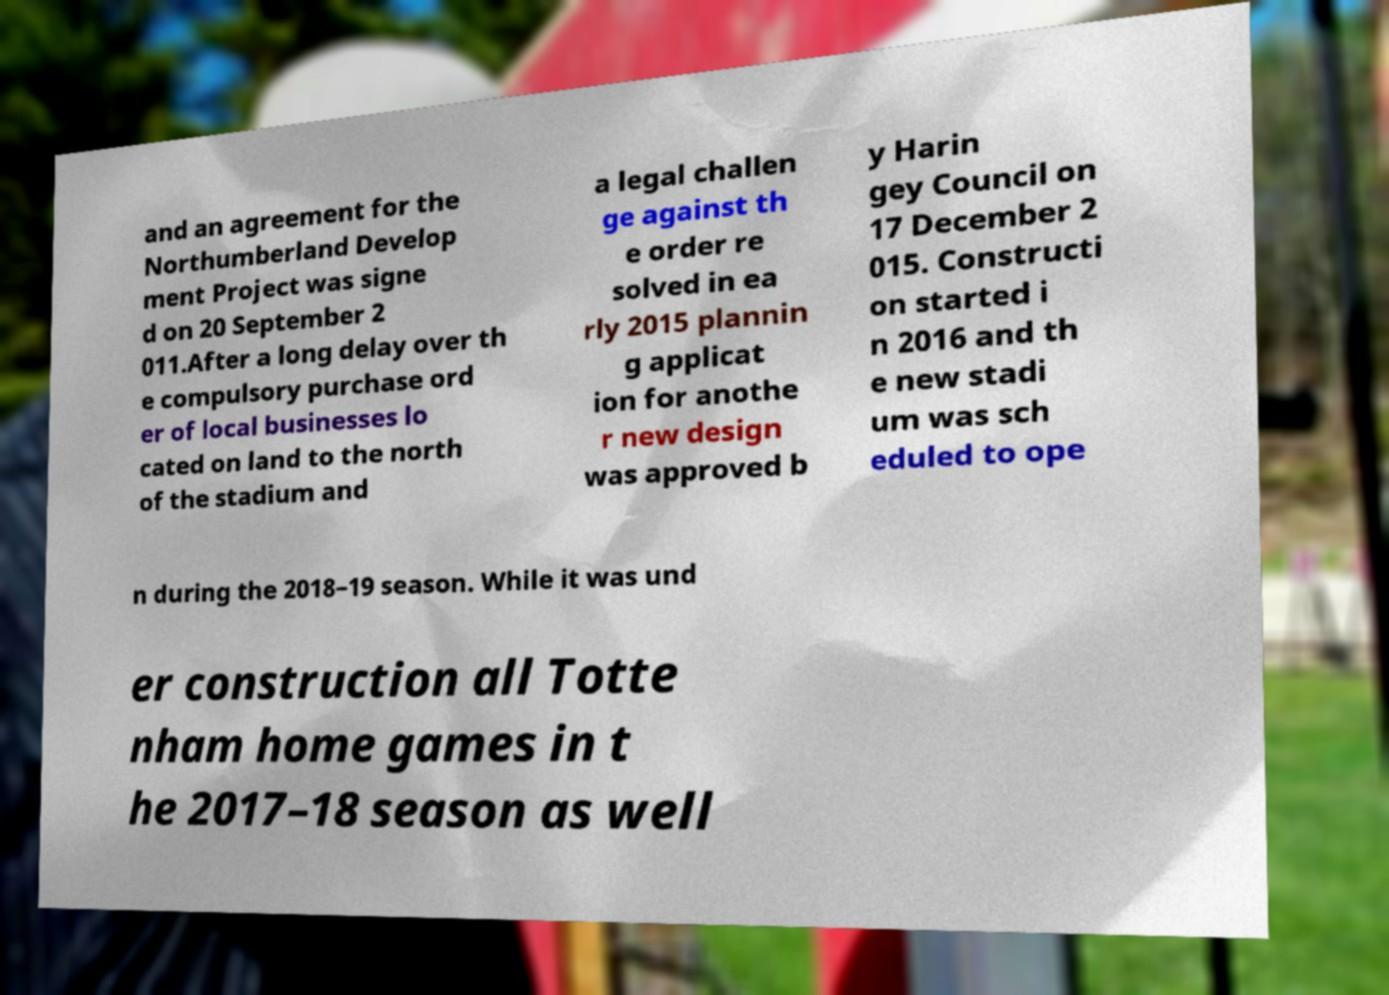What messages or text are displayed in this image? I need them in a readable, typed format. and an agreement for the Northumberland Develop ment Project was signe d on 20 September 2 011.After a long delay over th e compulsory purchase ord er of local businesses lo cated on land to the north of the stadium and a legal challen ge against th e order re solved in ea rly 2015 plannin g applicat ion for anothe r new design was approved b y Harin gey Council on 17 December 2 015. Constructi on started i n 2016 and th e new stadi um was sch eduled to ope n during the 2018–19 season. While it was und er construction all Totte nham home games in t he 2017–18 season as well 